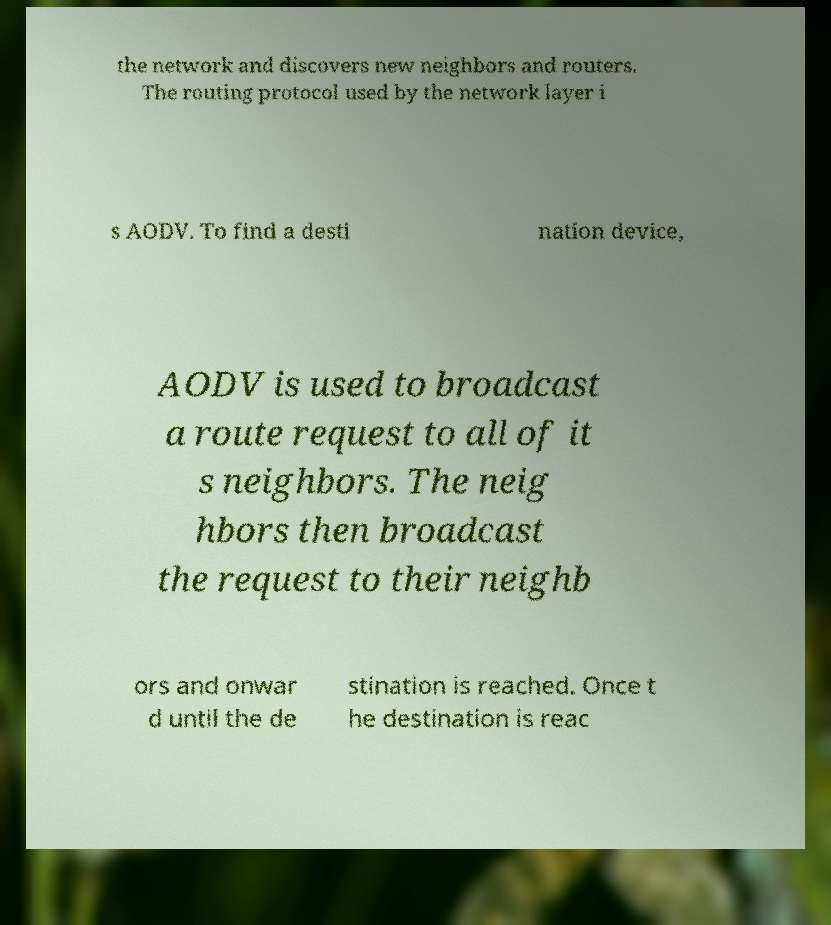Please read and relay the text visible in this image. What does it say? the network and discovers new neighbors and routers. The routing protocol used by the network layer i s AODV. To find a desti nation device, AODV is used to broadcast a route request to all of it s neighbors. The neig hbors then broadcast the request to their neighb ors and onwar d until the de stination is reached. Once t he destination is reac 